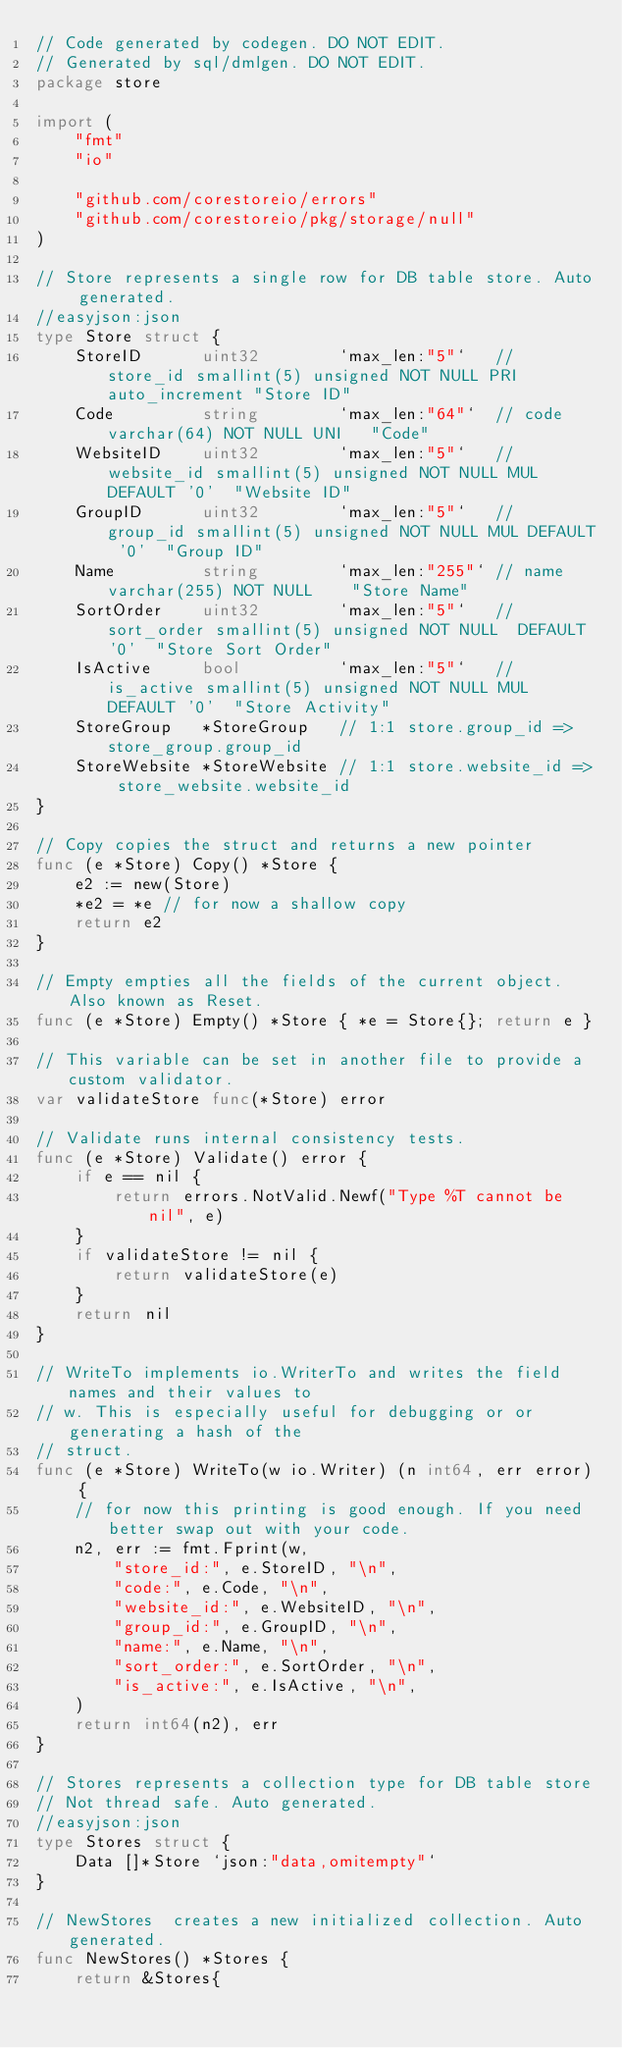<code> <loc_0><loc_0><loc_500><loc_500><_Go_>// Code generated by codegen. DO NOT EDIT.
// Generated by sql/dmlgen. DO NOT EDIT.
package store

import (
	"fmt"
	"io"

	"github.com/corestoreio/errors"
	"github.com/corestoreio/pkg/storage/null"
)

// Store represents a single row for DB table store. Auto generated.
//easyjson:json
type Store struct {
	StoreID      uint32        `max_len:"5"`   // store_id smallint(5) unsigned NOT NULL PRI  auto_increment "Store ID"
	Code         string        `max_len:"64"`  // code varchar(64) NOT NULL UNI   "Code"
	WebsiteID    uint32        `max_len:"5"`   // website_id smallint(5) unsigned NOT NULL MUL DEFAULT '0'  "Website ID"
	GroupID      uint32        `max_len:"5"`   // group_id smallint(5) unsigned NOT NULL MUL DEFAULT '0'  "Group ID"
	Name         string        `max_len:"255"` // name varchar(255) NOT NULL    "Store Name"
	SortOrder    uint32        `max_len:"5"`   // sort_order smallint(5) unsigned NOT NULL  DEFAULT '0'  "Store Sort Order"
	IsActive     bool          `max_len:"5"`   // is_active smallint(5) unsigned NOT NULL MUL DEFAULT '0'  "Store Activity"
	StoreGroup   *StoreGroup   // 1:1 store.group_id => store_group.group_id
	StoreWebsite *StoreWebsite // 1:1 store.website_id => store_website.website_id
}

// Copy copies the struct and returns a new pointer
func (e *Store) Copy() *Store {
	e2 := new(Store)
	*e2 = *e // for now a shallow copy
	return e2
}

// Empty empties all the fields of the current object. Also known as Reset.
func (e *Store) Empty() *Store { *e = Store{}; return e }

// This variable can be set in another file to provide a custom validator.
var validateStore func(*Store) error

// Validate runs internal consistency tests.
func (e *Store) Validate() error {
	if e == nil {
		return errors.NotValid.Newf("Type %T cannot be nil", e)
	}
	if validateStore != nil {
		return validateStore(e)
	}
	return nil
}

// WriteTo implements io.WriterTo and writes the field names and their values to
// w. This is especially useful for debugging or or generating a hash of the
// struct.
func (e *Store) WriteTo(w io.Writer) (n int64, err error) {
	// for now this printing is good enough. If you need better swap out with your code.
	n2, err := fmt.Fprint(w,
		"store_id:", e.StoreID, "\n",
		"code:", e.Code, "\n",
		"website_id:", e.WebsiteID, "\n",
		"group_id:", e.GroupID, "\n",
		"name:", e.Name, "\n",
		"sort_order:", e.SortOrder, "\n",
		"is_active:", e.IsActive, "\n",
	)
	return int64(n2), err
}

// Stores represents a collection type for DB table store
// Not thread safe. Auto generated.
//easyjson:json
type Stores struct {
	Data []*Store `json:"data,omitempty"`
}

// NewStores  creates a new initialized collection. Auto generated.
func NewStores() *Stores {
	return &Stores{</code> 